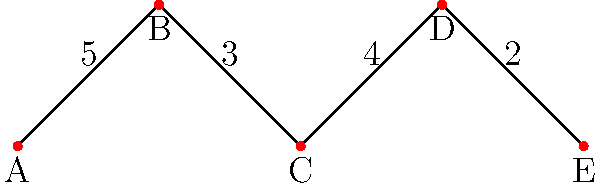The network diagram represents the deformation strength of different vehicle structure segments during a collision. Nodes represent critical points, and edge weights indicate the relative strength of each segment (higher values mean greater resistance to deformation). What is the weakest path from point A to point E, and what is its total strength? To find the weakest path from A to E, we need to analyze all possible paths and their total strengths:

1. Path A-B-C-D-E:
   Strength = 5 + 3 + 4 + 2 = 14

2. Path A-B-C-E:
   This path doesn't exist as there's no direct connection between C and E.

3. Path A-C-D-E:
   This path doesn't exist as there's no direct connection between A and C.

The only valid path from A to E is A-B-C-D-E, which has a total strength of 14.

To determine if this is the weakest path, we need to identify the segment with the lowest strength, as it represents the weakest link in the structure:

A-B: 5
B-C: 3
C-D: 4
D-E: 2

The weakest segment is D-E with a strength of 2. This means that the path A-B-C-D-E is indeed the weakest path, as it includes this segment.

The total strength of this path is the sum of all segment strengths: 5 + 3 + 4 + 2 = 14.
Answer: A-B-C-D-E, 14 